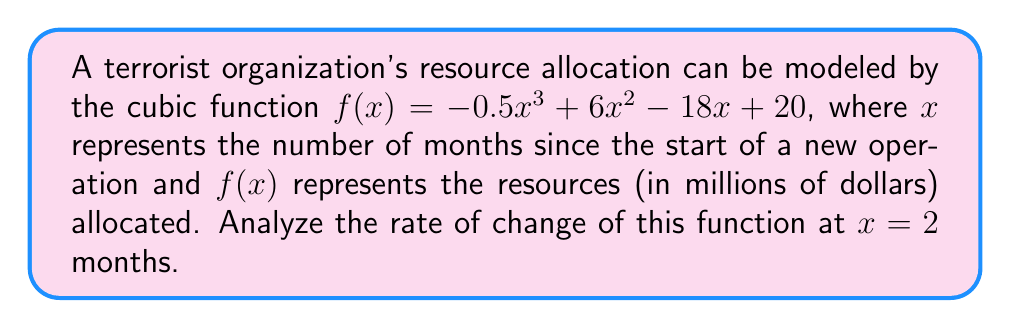Solve this math problem. To analyze the rate of change at a specific point, we need to find the derivative of the function and evaluate it at the given point.

Step 1: Find the derivative of $f(x)$.
$f'(x) = \frac{d}{dx}(-0.5x^3 + 6x^2 - 18x + 20)$
$f'(x) = -1.5x^2 + 12x - 18$

Step 2: Evaluate the derivative at $x = 2$.
$f'(2) = -1.5(2)^2 + 12(2) - 18$
$f'(2) = -1.5(4) + 24 - 18$
$f'(2) = -6 + 24 - 18$
$f'(2) = 0$

Step 3: Interpret the result.
The rate of change at $x = 2$ is 0, which means the function has a horizontal tangent line at this point. This indicates that the resource allocation is neither increasing nor decreasing at 2 months, suggesting a temporary stabilization in the allocation of resources.
Answer: 0 million dollars per month 